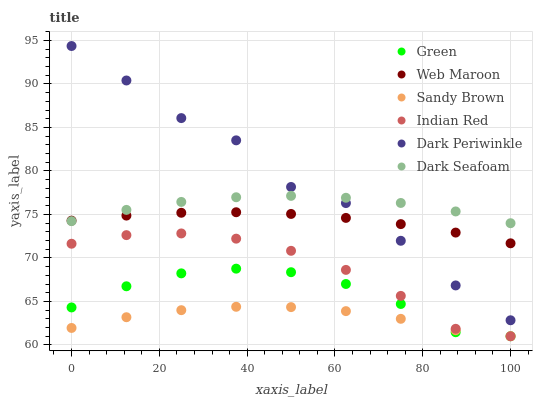Does Sandy Brown have the minimum area under the curve?
Answer yes or no. Yes. Does Dark Periwinkle have the maximum area under the curve?
Answer yes or no. Yes. Does Dark Seafoam have the minimum area under the curve?
Answer yes or no. No. Does Dark Seafoam have the maximum area under the curve?
Answer yes or no. No. Is Web Maroon the smoothest?
Answer yes or no. Yes. Is Dark Periwinkle the roughest?
Answer yes or no. Yes. Is Dark Seafoam the smoothest?
Answer yes or no. No. Is Dark Seafoam the roughest?
Answer yes or no. No. Does Green have the lowest value?
Answer yes or no. Yes. Does Dark Seafoam have the lowest value?
Answer yes or no. No. Does Dark Periwinkle have the highest value?
Answer yes or no. Yes. Does Dark Seafoam have the highest value?
Answer yes or no. No. Is Indian Red less than Web Maroon?
Answer yes or no. Yes. Is Dark Seafoam greater than Indian Red?
Answer yes or no. Yes. Does Dark Periwinkle intersect Web Maroon?
Answer yes or no. Yes. Is Dark Periwinkle less than Web Maroon?
Answer yes or no. No. Is Dark Periwinkle greater than Web Maroon?
Answer yes or no. No. Does Indian Red intersect Web Maroon?
Answer yes or no. No. 